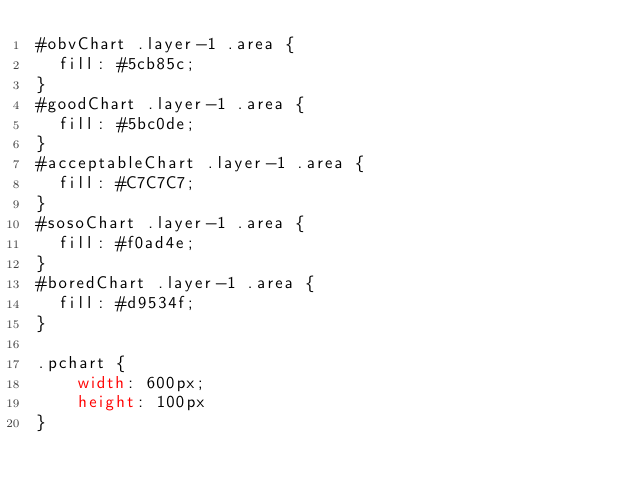Convert code to text. <code><loc_0><loc_0><loc_500><loc_500><_CSS_>#obvChart .layer-1 .area {
  fill: #5cb85c;
}
#goodChart .layer-1 .area {
  fill: #5bc0de;
}
#acceptableChart .layer-1 .area {
  fill: #C7C7C7;
}
#sosoChart .layer-1 .area {
  fill: #f0ad4e;
}
#boredChart .layer-1 .area {
  fill: #d9534f;
}

.pchart {
    width: 600px; 
    height: 100px
}</code> 